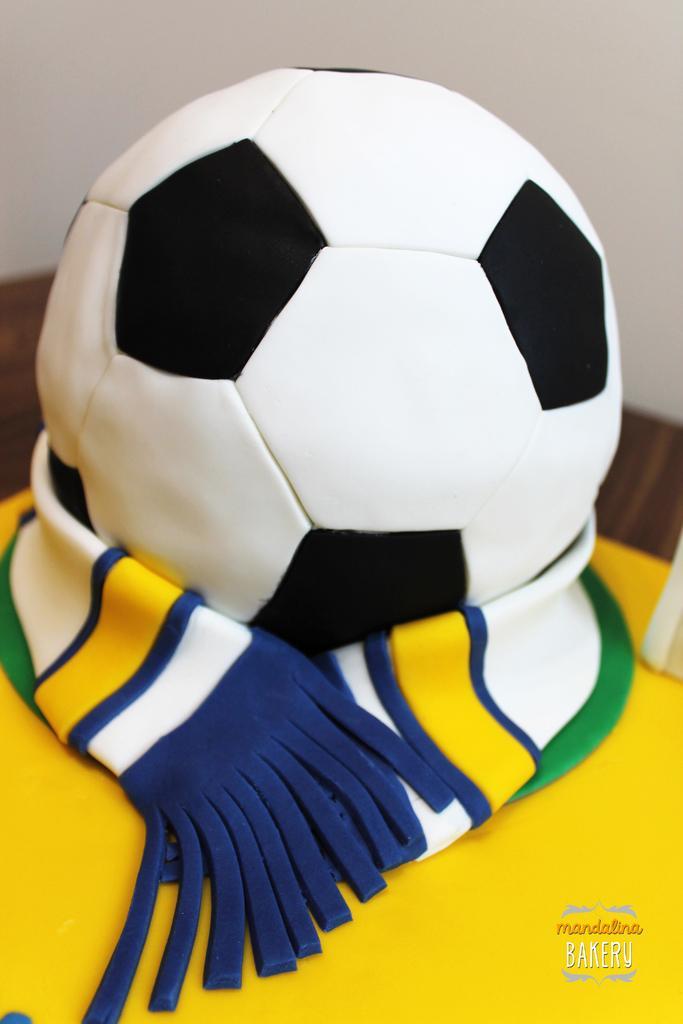Please provide a concise description of this image. In the foreground of this image, it seems like a cake. On the bottom, there is a yellow cloth. In the middle, there is a ball. In the background, there is a wall. 